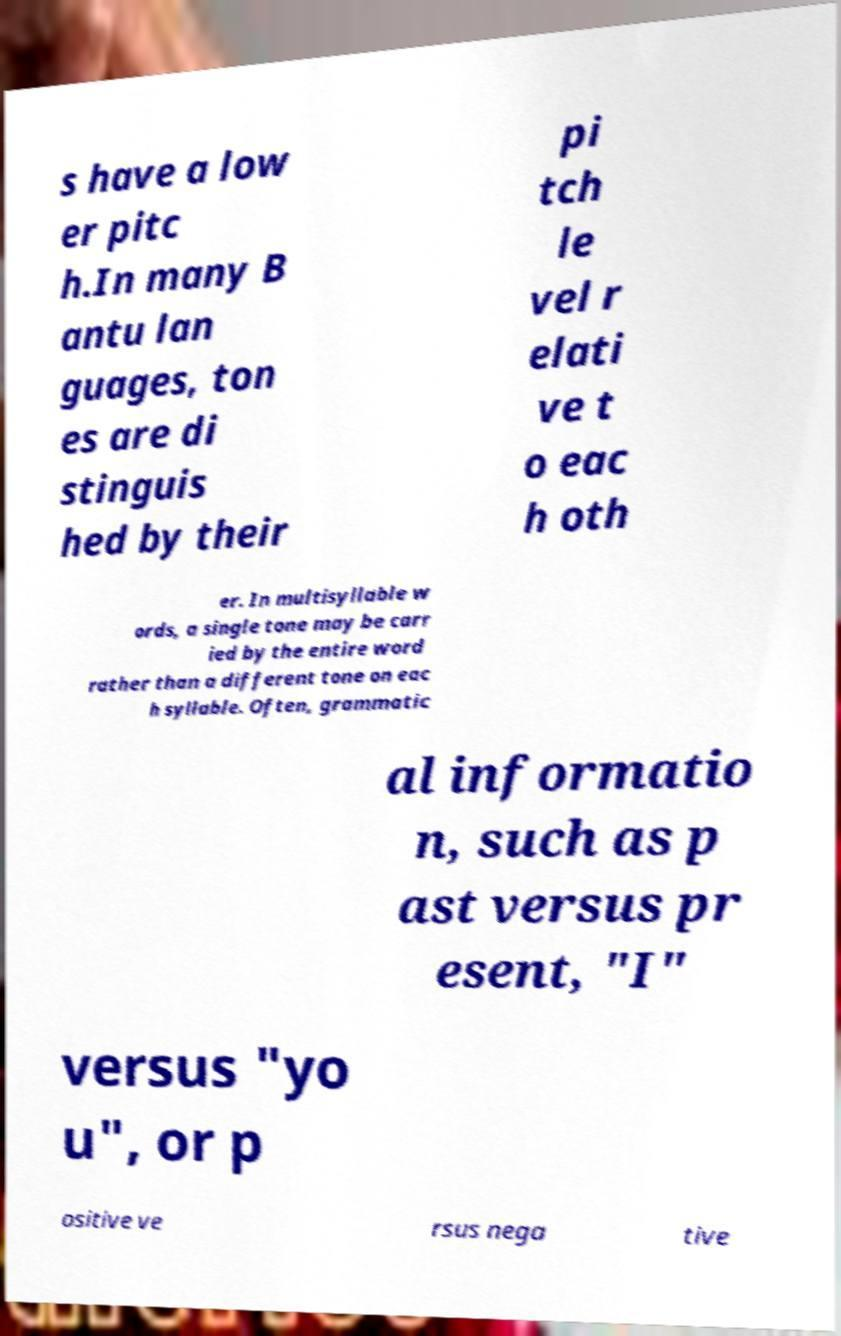Please identify and transcribe the text found in this image. s have a low er pitc h.In many B antu lan guages, ton es are di stinguis hed by their pi tch le vel r elati ve t o eac h oth er. In multisyllable w ords, a single tone may be carr ied by the entire word rather than a different tone on eac h syllable. Often, grammatic al informatio n, such as p ast versus pr esent, "I" versus "yo u", or p ositive ve rsus nega tive 